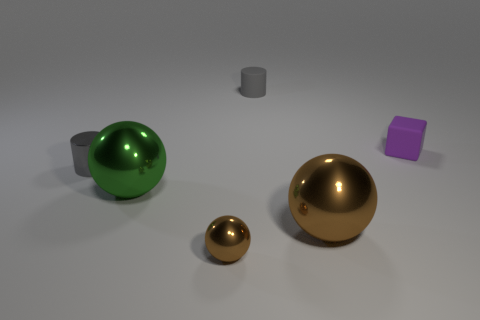Is there any other thing that is the same shape as the purple rubber thing?
Your response must be concise. No. What is the color of the small cylinder that is made of the same material as the small sphere?
Offer a terse response. Gray. Is the number of small gray matte objects behind the matte cylinder the same as the number of tiny balls?
Ensure brevity in your answer.  No. There is a rubber object to the left of the purple matte object; does it have the same size as the large green metal thing?
Provide a short and direct response. No. The metal cylinder that is the same size as the block is what color?
Provide a short and direct response. Gray. Is there a large green shiny sphere in front of the sphere that is to the right of the brown thing in front of the large brown metallic object?
Your response must be concise. No. There is a small thing right of the big brown ball; what is its material?
Ensure brevity in your answer.  Rubber. Does the tiny gray metal object have the same shape as the small object that is behind the purple block?
Ensure brevity in your answer.  Yes. Are there an equal number of tiny cylinders that are right of the gray metallic object and large objects that are left of the small gray rubber thing?
Provide a succinct answer. Yes. What number of other things are the same material as the big green object?
Your answer should be very brief. 3. 